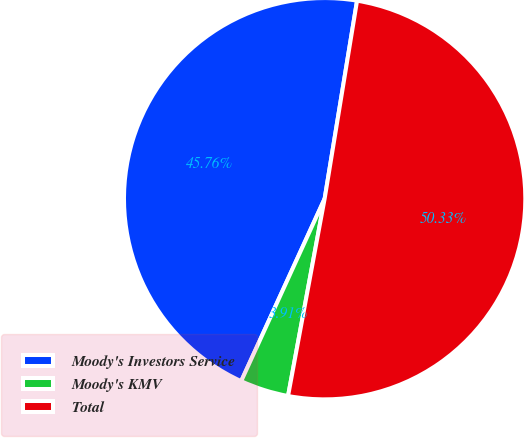<chart> <loc_0><loc_0><loc_500><loc_500><pie_chart><fcel>Moody's Investors Service<fcel>Moody's KMV<fcel>Total<nl><fcel>45.76%<fcel>3.91%<fcel>50.34%<nl></chart> 